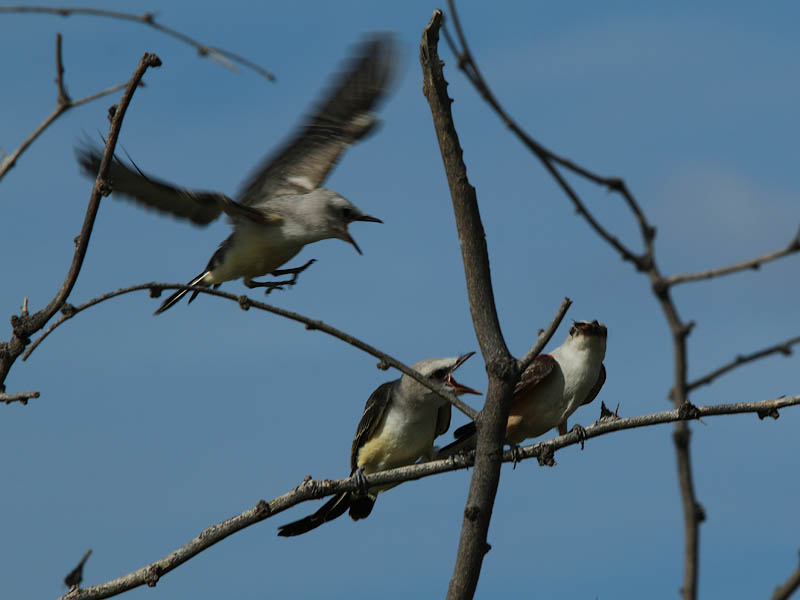Observing the habitat in which these birds are found, what can you say about their natural environment? Birds perched on what appear to be the bare branches of deciduous trees, set against a clear blue sky, might indicate a habitat with open woodlands or forest edges. These environments provide ample opportunities for perching and surveying for insects or other food sources. Such habitats are critical for offering suitable nesting sites and enough food supply, particularly during breeding season when the demand is higher due to the need to feed the young. 